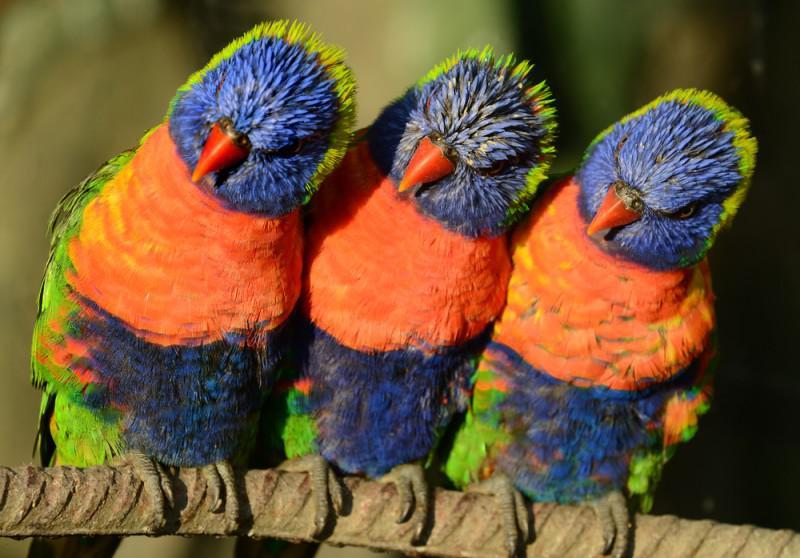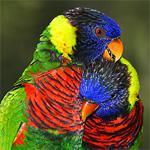The first image is the image on the left, the second image is the image on the right. Given the left and right images, does the statement "There is exactly three parrots in the right image." hold true? Answer yes or no. No. The first image is the image on the left, the second image is the image on the right. Assess this claim about the two images: "A total of six birds are shown, and at least some are perching on light-colored, smooth wood.". Correct or not? Answer yes or no. No. 